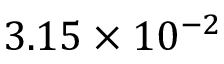Convert formula to latex. <formula><loc_0><loc_0><loc_500><loc_500>3 . 1 5 \times 1 0 ^ { - 2 }</formula> 